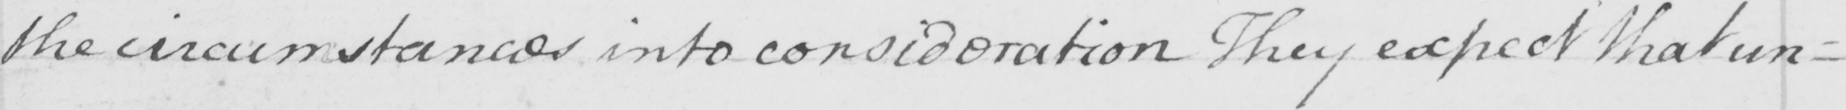What is written in this line of handwriting? the circumstance into consideration . They expect that un= 